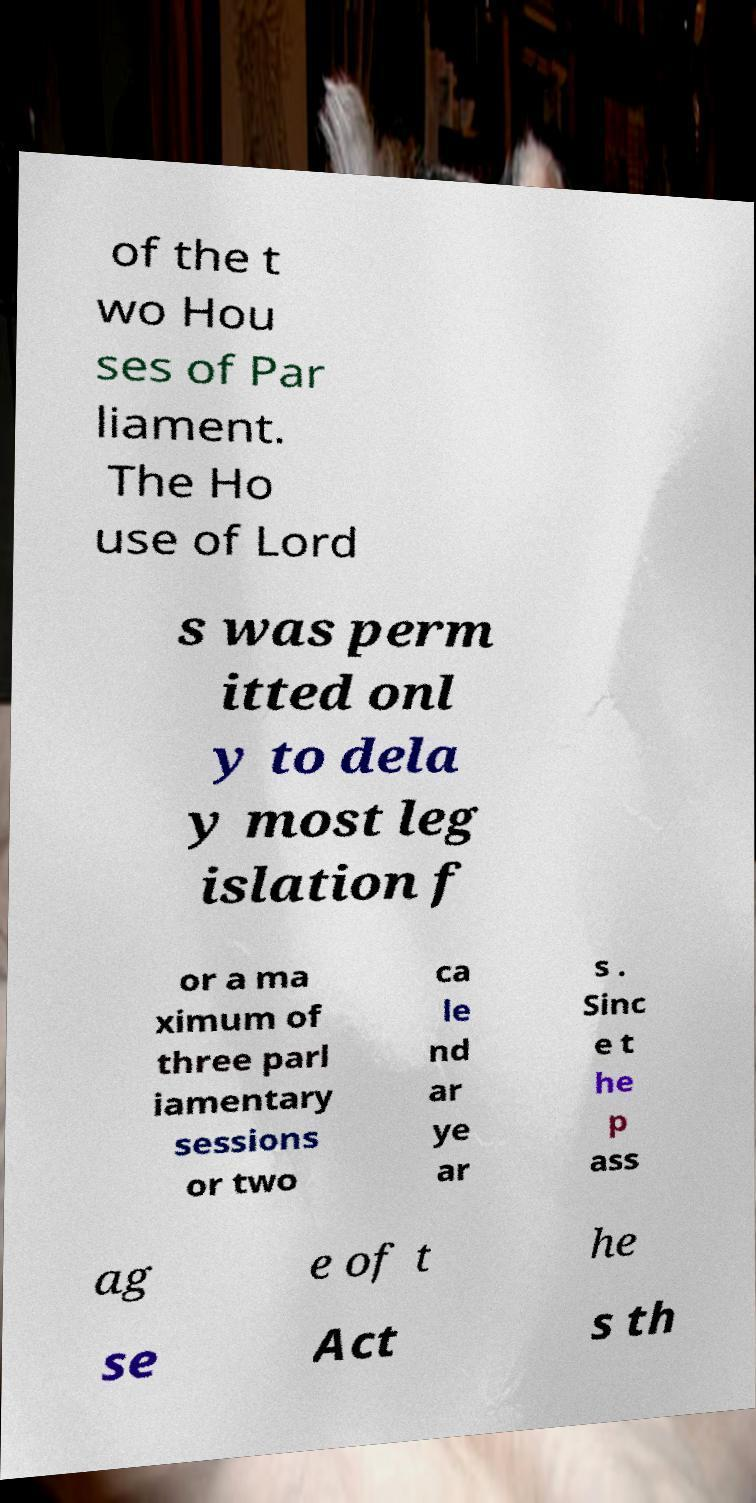Could you extract and type out the text from this image? of the t wo Hou ses of Par liament. The Ho use of Lord s was perm itted onl y to dela y most leg islation f or a ma ximum of three parl iamentary sessions or two ca le nd ar ye ar s . Sinc e t he p ass ag e of t he se Act s th 